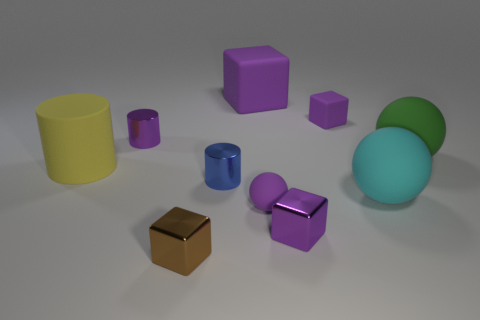How many purple cubes must be subtracted to get 1 purple cubes? 2 Subtract all yellow balls. How many purple blocks are left? 3 Subtract all cylinders. How many objects are left? 7 Add 6 green rubber things. How many green rubber things are left? 7 Add 9 green rubber balls. How many green rubber balls exist? 10 Subtract 1 cyan spheres. How many objects are left? 9 Subtract all small blue metallic things. Subtract all big matte objects. How many objects are left? 5 